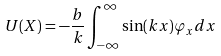<formula> <loc_0><loc_0><loc_500><loc_500>U ( X ) = - \frac { b } { k } \int _ { - \infty } ^ { \infty } \sin ( k x ) \varphi _ { x } d x</formula> 